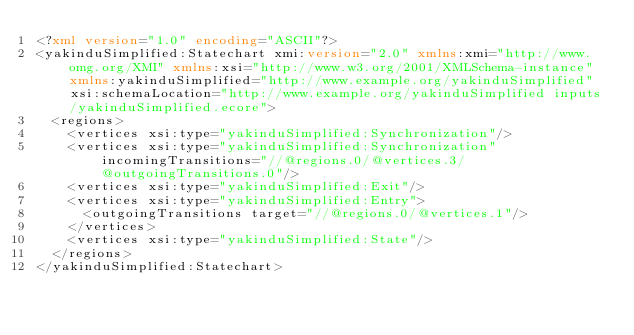<code> <loc_0><loc_0><loc_500><loc_500><_XML_><?xml version="1.0" encoding="ASCII"?>
<yakinduSimplified:Statechart xmi:version="2.0" xmlns:xmi="http://www.omg.org/XMI" xmlns:xsi="http://www.w3.org/2001/XMLSchema-instance" xmlns:yakinduSimplified="http://www.example.org/yakinduSimplified" xsi:schemaLocation="http://www.example.org/yakinduSimplified inputs/yakinduSimplified.ecore">
  <regions>
    <vertices xsi:type="yakinduSimplified:Synchronization"/>
    <vertices xsi:type="yakinduSimplified:Synchronization" incomingTransitions="//@regions.0/@vertices.3/@outgoingTransitions.0"/>
    <vertices xsi:type="yakinduSimplified:Exit"/>
    <vertices xsi:type="yakinduSimplified:Entry">
      <outgoingTransitions target="//@regions.0/@vertices.1"/>
    </vertices>
    <vertices xsi:type="yakinduSimplified:State"/>
  </regions>
</yakinduSimplified:Statechart>
</code> 